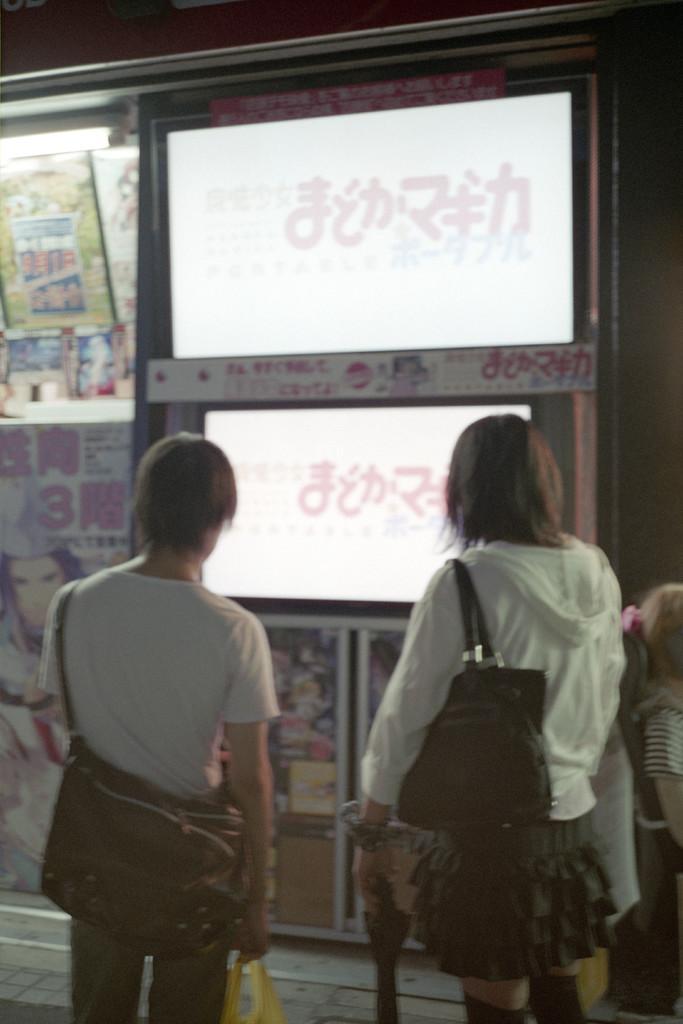Could you give a brief overview of what you see in this image? In this image there are two persons wearing a bag and holding an object, there is a display board, there are posters, there is a light. 